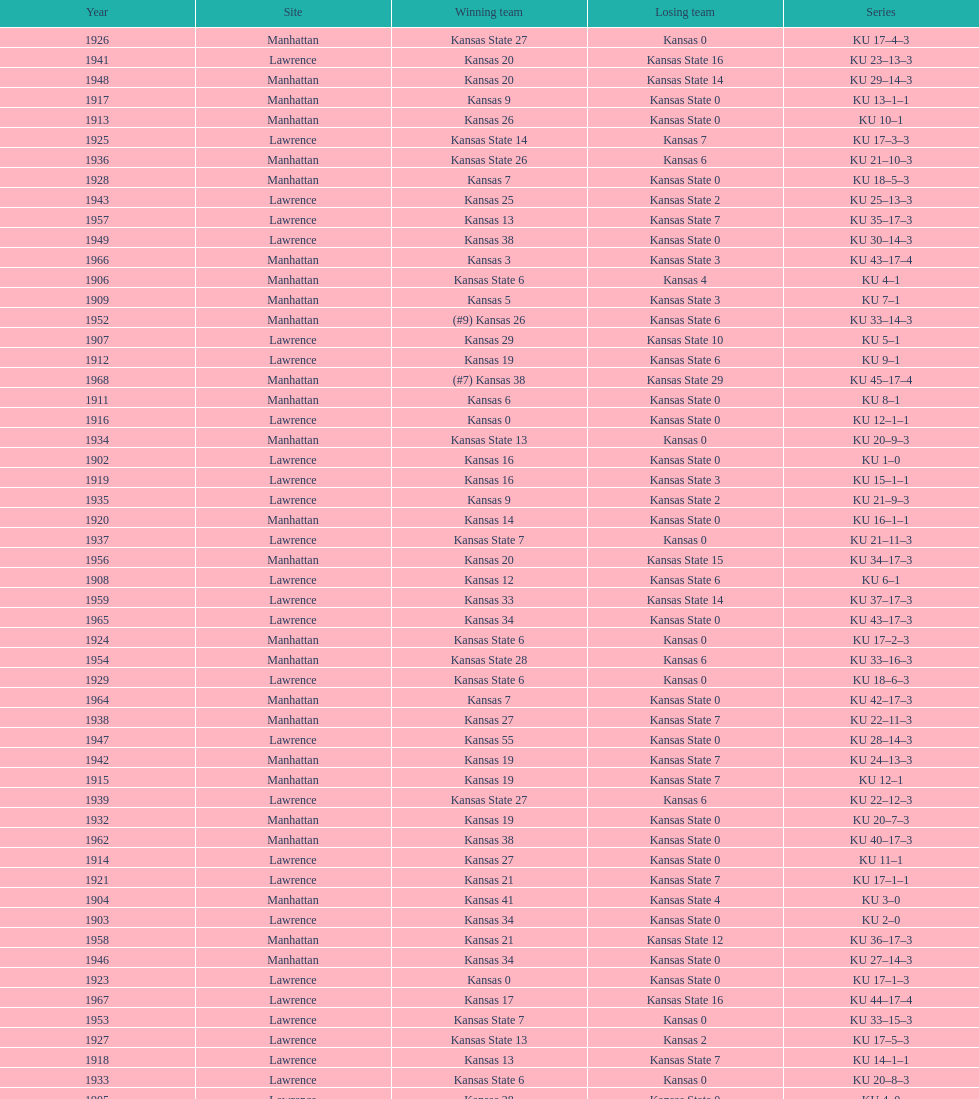Would you mind parsing the complete table? {'header': ['Year', 'Site', 'Winning team', 'Losing team', 'Series'], 'rows': [['1926', 'Manhattan', 'Kansas State 27', 'Kansas 0', 'KU 17–4–3'], ['1941', 'Lawrence', 'Kansas 20', 'Kansas State 16', 'KU 23–13–3'], ['1948', 'Manhattan', 'Kansas 20', 'Kansas State 14', 'KU 29–14–3'], ['1917', 'Manhattan', 'Kansas 9', 'Kansas State 0', 'KU 13–1–1'], ['1913', 'Manhattan', 'Kansas 26', 'Kansas State 0', 'KU 10–1'], ['1925', 'Lawrence', 'Kansas State 14', 'Kansas 7', 'KU 17–3–3'], ['1936', 'Manhattan', 'Kansas State 26', 'Kansas 6', 'KU 21–10–3'], ['1928', 'Manhattan', 'Kansas 7', 'Kansas State 0', 'KU 18–5–3'], ['1943', 'Lawrence', 'Kansas 25', 'Kansas State 2', 'KU 25–13–3'], ['1957', 'Lawrence', 'Kansas 13', 'Kansas State 7', 'KU 35–17–3'], ['1949', 'Lawrence', 'Kansas 38', 'Kansas State 0', 'KU 30–14–3'], ['1966', 'Manhattan', 'Kansas 3', 'Kansas State 3', 'KU 43–17–4'], ['1906', 'Manhattan', 'Kansas State 6', 'Kansas 4', 'KU 4–1'], ['1909', 'Manhattan', 'Kansas 5', 'Kansas State 3', 'KU 7–1'], ['1952', 'Manhattan', '(#9) Kansas 26', 'Kansas State 6', 'KU 33–14–3'], ['1907', 'Lawrence', 'Kansas 29', 'Kansas State 10', 'KU 5–1'], ['1912', 'Lawrence', 'Kansas 19', 'Kansas State 6', 'KU 9–1'], ['1968', 'Manhattan', '(#7) Kansas 38', 'Kansas State 29', 'KU 45–17–4'], ['1911', 'Manhattan', 'Kansas 6', 'Kansas State 0', 'KU 8–1'], ['1916', 'Lawrence', 'Kansas 0', 'Kansas State 0', 'KU 12–1–1'], ['1934', 'Manhattan', 'Kansas State 13', 'Kansas 0', 'KU 20–9–3'], ['1902', 'Lawrence', 'Kansas 16', 'Kansas State 0', 'KU 1–0'], ['1919', 'Lawrence', 'Kansas 16', 'Kansas State 3', 'KU 15–1–1'], ['1935', 'Lawrence', 'Kansas 9', 'Kansas State 2', 'KU 21–9–3'], ['1920', 'Manhattan', 'Kansas 14', 'Kansas State 0', 'KU 16–1–1'], ['1937', 'Lawrence', 'Kansas State 7', 'Kansas 0', 'KU 21–11–3'], ['1956', 'Manhattan', 'Kansas 20', 'Kansas State 15', 'KU 34–17–3'], ['1908', 'Lawrence', 'Kansas 12', 'Kansas State 6', 'KU 6–1'], ['1959', 'Lawrence', 'Kansas 33', 'Kansas State 14', 'KU 37–17–3'], ['1965', 'Lawrence', 'Kansas 34', 'Kansas State 0', 'KU 43–17–3'], ['1924', 'Manhattan', 'Kansas State 6', 'Kansas 0', 'KU 17–2–3'], ['1954', 'Manhattan', 'Kansas State 28', 'Kansas 6', 'KU 33–16–3'], ['1929', 'Lawrence', 'Kansas State 6', 'Kansas 0', 'KU 18–6–3'], ['1964', 'Manhattan', 'Kansas 7', 'Kansas State 0', 'KU 42–17–3'], ['1938', 'Manhattan', 'Kansas 27', 'Kansas State 7', 'KU 22–11–3'], ['1947', 'Lawrence', 'Kansas 55', 'Kansas State 0', 'KU 28–14–3'], ['1942', 'Manhattan', 'Kansas 19', 'Kansas State 7', 'KU 24–13–3'], ['1915', 'Manhattan', 'Kansas 19', 'Kansas State 7', 'KU 12–1'], ['1939', 'Lawrence', 'Kansas State 27', 'Kansas 6', 'KU 22–12–3'], ['1932', 'Manhattan', 'Kansas 19', 'Kansas State 0', 'KU 20–7–3'], ['1962', 'Manhattan', 'Kansas 38', 'Kansas State 0', 'KU 40–17–3'], ['1914', 'Lawrence', 'Kansas 27', 'Kansas State 0', 'KU 11–1'], ['1921', 'Lawrence', 'Kansas 21', 'Kansas State 7', 'KU 17–1–1'], ['1904', 'Manhattan', 'Kansas 41', 'Kansas State 4', 'KU 3–0'], ['1903', 'Lawrence', 'Kansas 34', 'Kansas State 0', 'KU 2–0'], ['1958', 'Manhattan', 'Kansas 21', 'Kansas State 12', 'KU 36–17–3'], ['1946', 'Manhattan', 'Kansas 34', 'Kansas State 0', 'KU 27–14–3'], ['1923', 'Lawrence', 'Kansas 0', 'Kansas State 0', 'KU 17–1–3'], ['1967', 'Lawrence', 'Kansas 17', 'Kansas State 16', 'KU 44–17–4'], ['1953', 'Lawrence', 'Kansas State 7', 'Kansas 0', 'KU 33–15–3'], ['1927', 'Lawrence', 'Kansas State 13', 'Kansas 2', 'KU 17–5–3'], ['1918', 'Lawrence', 'Kansas 13', 'Kansas State 7', 'KU 14–1–1'], ['1933', 'Lawrence', 'Kansas State 6', 'Kansas 0', 'KU 20–8–3'], ['1905', 'Lawrence', 'Kansas 28', 'Kansas State 0', 'KU 4–0'], ['1931', 'Lawrence', 'Kansas State 13', 'Kansas 0', 'KU 19–7–3'], ['1960', 'Manhattan', 'Kansas 41', 'Kansas State 0', 'KU 38–17–3'], ['1961', 'Lawrence', 'Kansas 34', 'Kansas State 0', 'KU 39–17–3'], ['1922', 'Manhattan', 'Kansas 7', 'Kansas State 7', 'KU 17–1–2'], ['1963', 'Lawrence', 'Kansas 34', 'Kansas State 0', 'KU 41–17–3'], ['1940', 'Manhattan', 'Kansas State 20', 'Kansas 0', 'KU 22–13–3'], ['1944', 'Manhattan', 'Kansas State 24', 'Kansas 18', 'KU 25–14–3'], ['1945', 'Lawrence', 'Kansas 27', 'Kansas State 0', 'KU 26–14–3'], ['1955', 'Lawrence', 'Kansas State 46', 'Kansas 0', 'KU 33–17–3'], ['1950', 'Manhattan', 'Kansas 47', 'Kansas State 7', 'KU 31–14–3'], ['1951', 'Lawrence', 'Kansas 33', 'Kansas State 14', 'KU 32–14–3'], ['1930', 'Manhattan', 'Kansas 14', 'Kansas State 0', 'KU 19–6–3']]} What is the total number of games played? 66. 